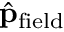Convert formula to latex. <formula><loc_0><loc_0><loc_500><loc_500>\hat { p } _ { f i e l d }</formula> 